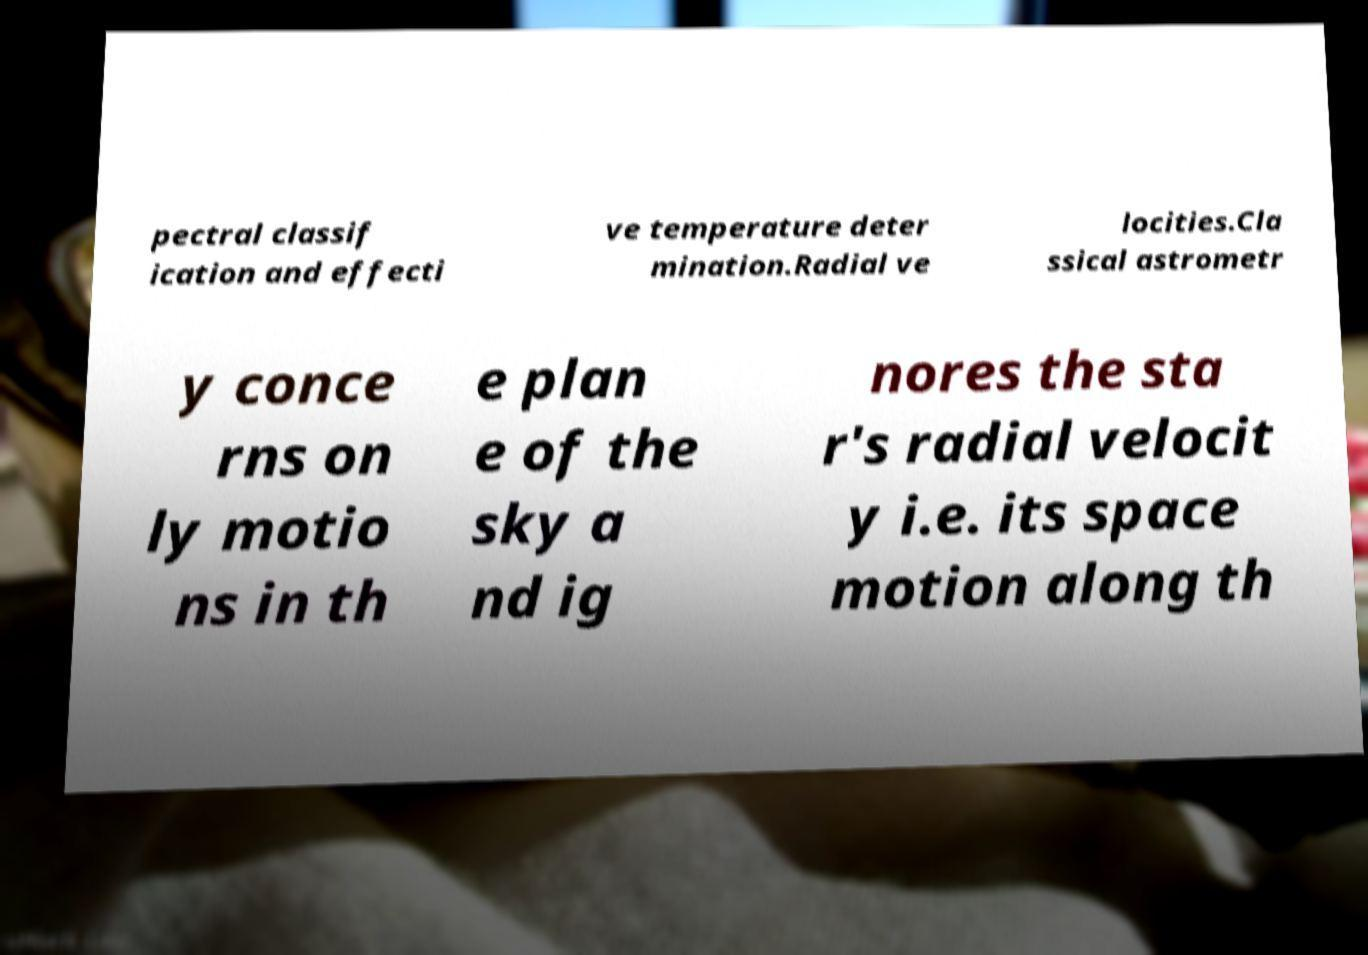Could you assist in decoding the text presented in this image and type it out clearly? pectral classif ication and effecti ve temperature deter mination.Radial ve locities.Cla ssical astrometr y conce rns on ly motio ns in th e plan e of the sky a nd ig nores the sta r's radial velocit y i.e. its space motion along th 